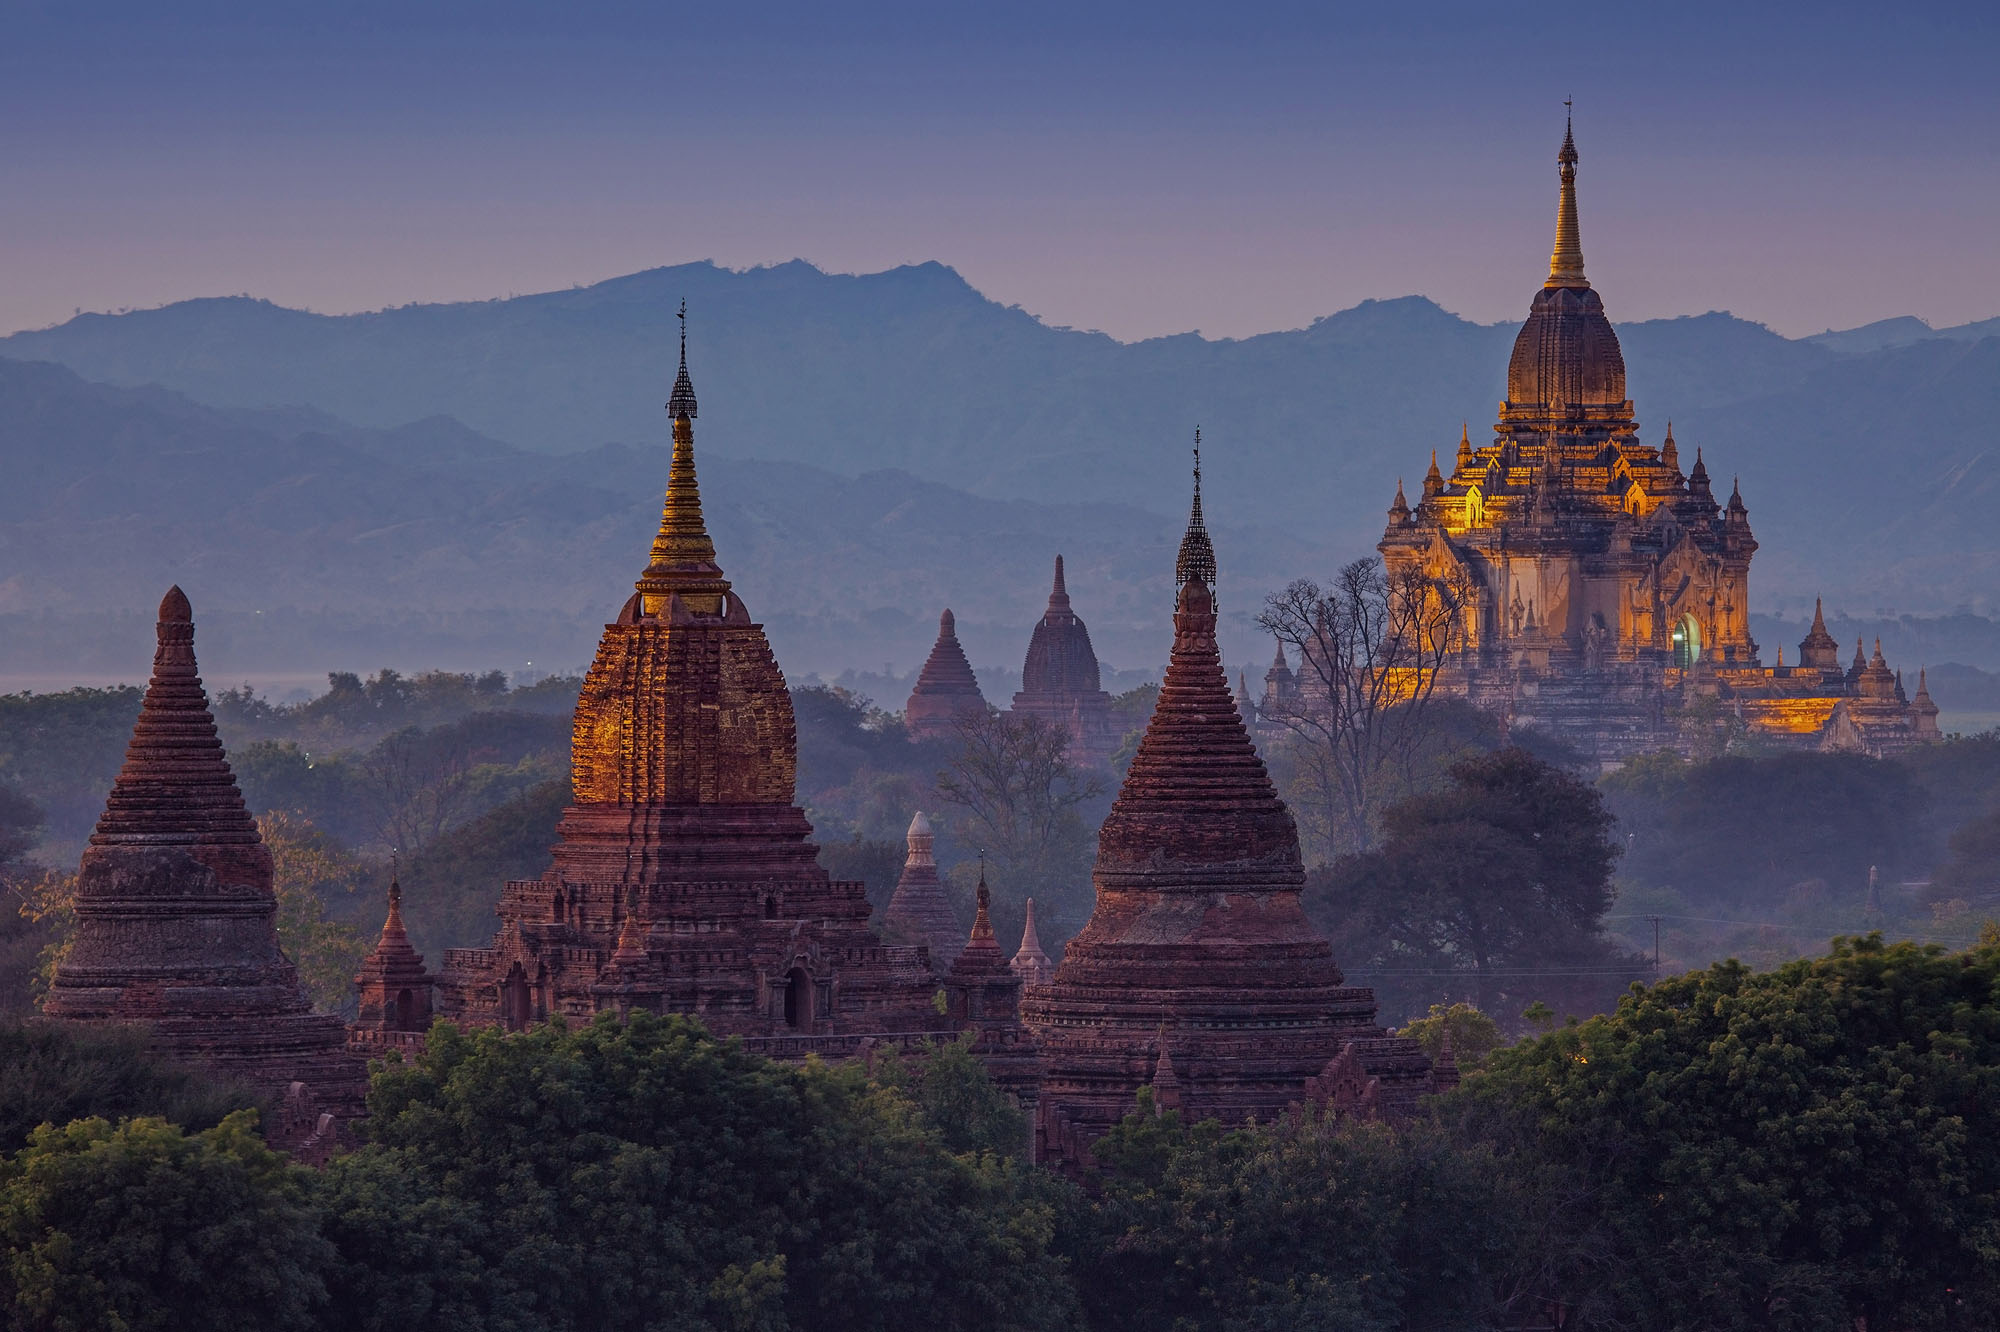Look at this majestic panorama! Can you tell me more about the architectural styles visible here? Certainly! This image showcases a beautiful mix of architectural styles primarily from ancient Burmese temple design. The prominent bell-shaped structures are characteristic of stupas, designed to hold relics and serve religious purposes. The pointed spires, known as 'hti,' are golden and glistening from the setting sun, symbolizing spirituality and reverence. The large temple on the right, likely Ananda Temple, exhibits a distinctive tiered design with a gilded top. This arrangement epitomizes the blending of Theravada Buddhist influences with indigenous architectural practices. The intricate carvings and ornate details on these temples speak volumes about the artistic prowess and devotional intensity of ancient Burmese culture. What could be a daily life scene in this area during the height of its use? Every day in ancient Bagan was a symphony of devotional activities and vibrant community life. Monks clad in saffron robes would walk through the city, collecting alms from devotees who offered food in return for blessings. The air would be filled with the sound of chanting, the clinking of bells, and the aroma of incense. Local artisans would be seen meticulously working on sculptures, weaving textiles, or carving intricate designs on the doorways and walls of the temples. Traders from distant lands would arrive with spices, precious stones, and exotic goods, contributing to a bustling bazaar atmosphere. Pilgrims traversed the temple fields, seeking solace and enlightenment, while the setting sun cast a golden hue across the serene landscape, creating an almost ethereal ambiance. Festivals and religious ceremonies were frequently held, turning the city into a grand stage of spiritual celebration and community bonding. 